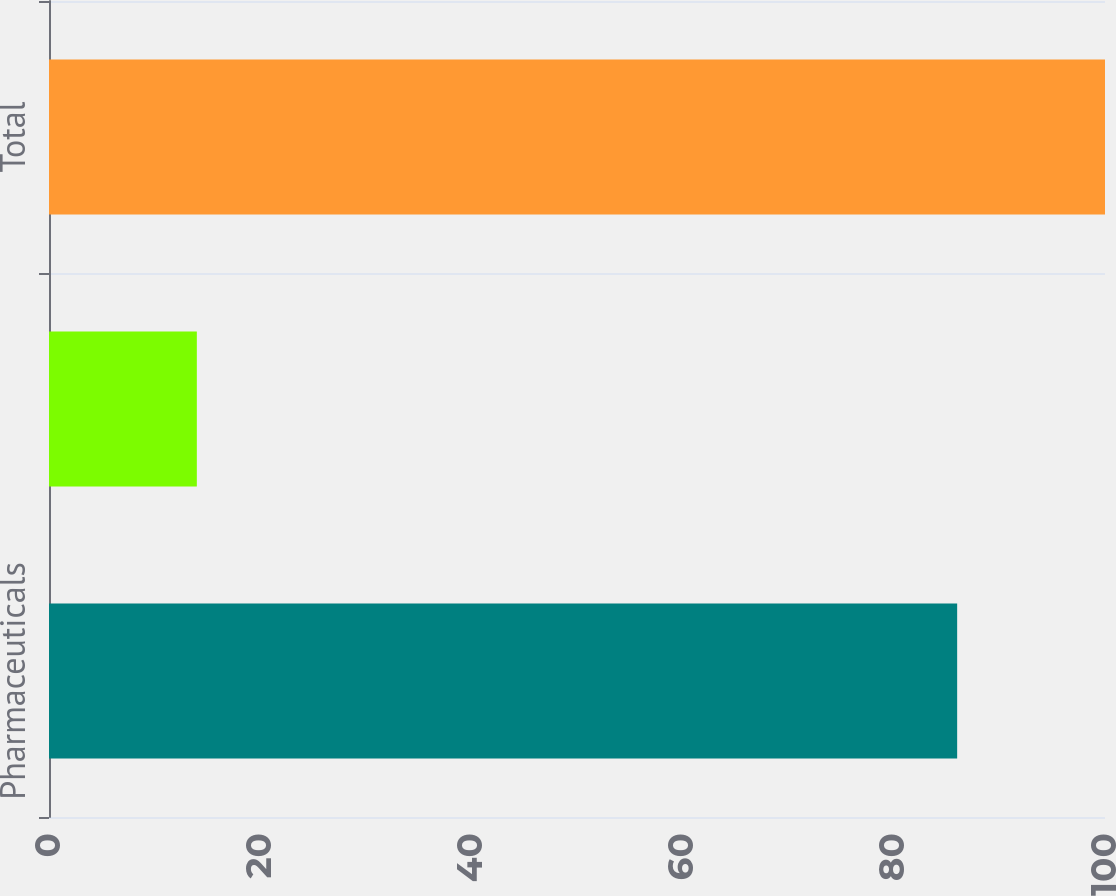Convert chart. <chart><loc_0><loc_0><loc_500><loc_500><bar_chart><fcel>Pharmaceuticals<fcel>Nutritionals<fcel>Total<nl><fcel>86<fcel>14<fcel>100<nl></chart> 